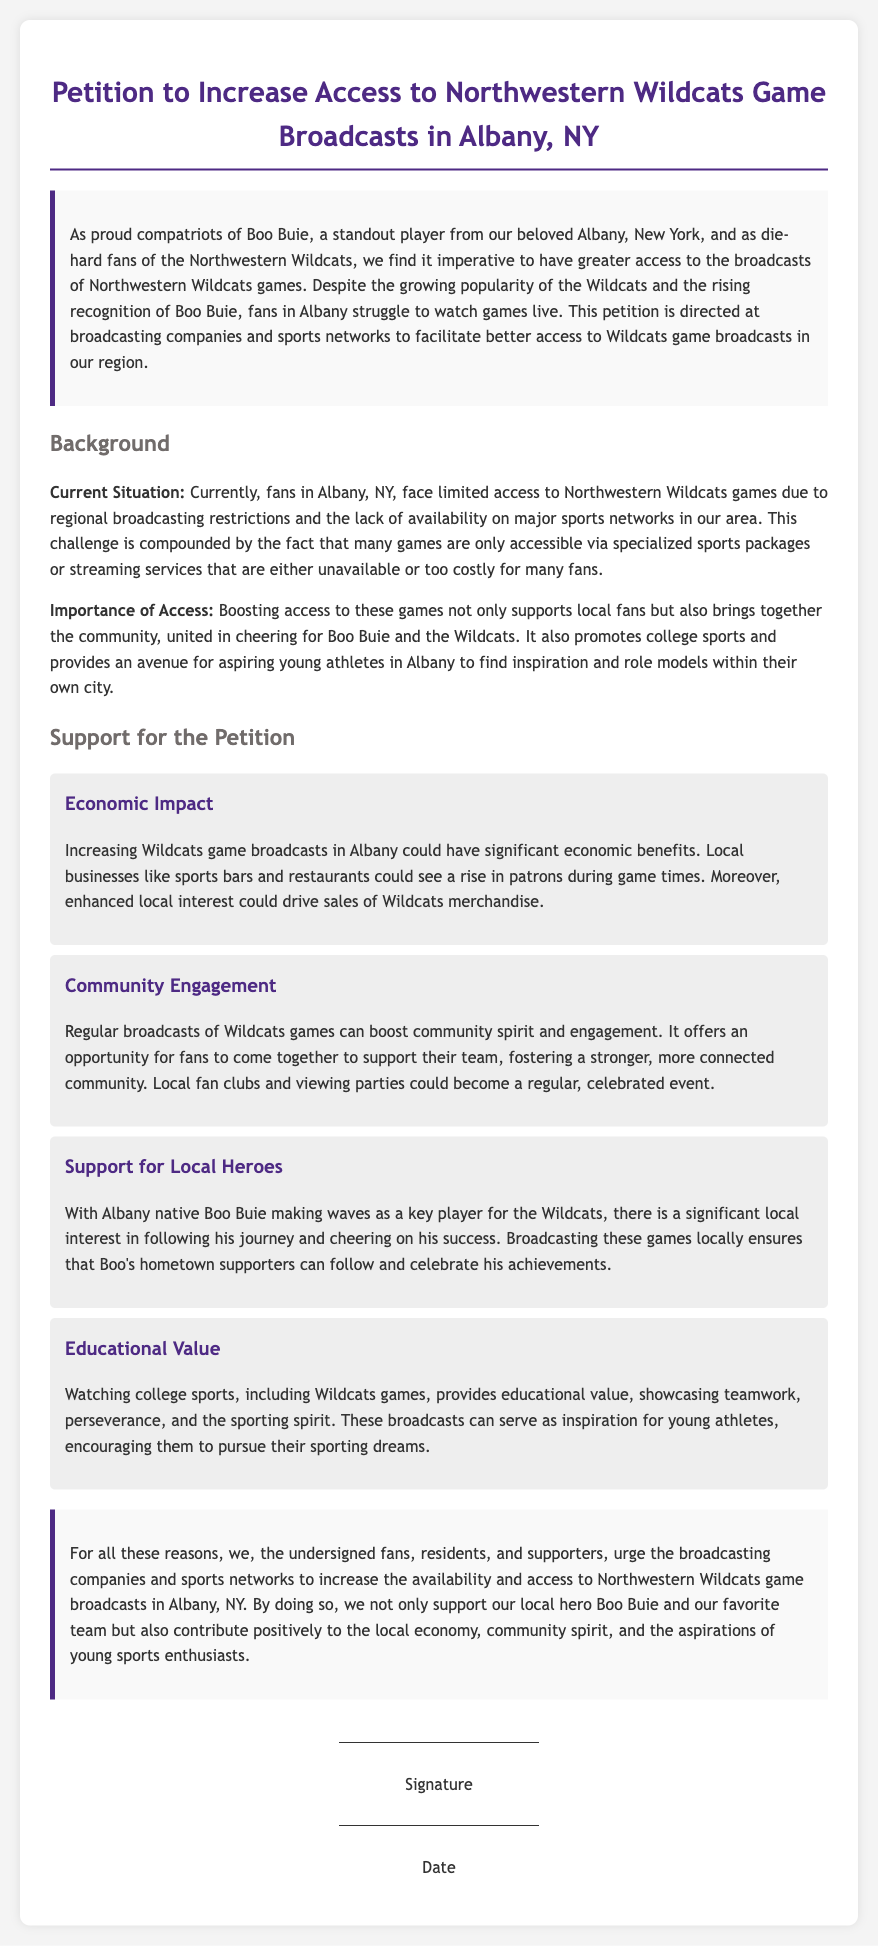What is the title of the petition? The title of the petition is stated at the top of the document.
Answer: Petition to Increase Access to Northwestern Wildcats Game Broadcasts in Albany, NY Who is referenced as a standout player from Albany? The document mentions a player who is significant to the petition and the community.
Answer: Boo Buie What is one reason for increasing broadcasts of the games? The document lists various reasons in support of the petition, including economic and community benefits.
Answer: Economic Impact What is the significance of Boo Buie in this petition? The document explains Boo Buie's importance to local fans and his connection to Albany.
Answer: Local Heroes What is mentioned as a potential benefit to local businesses? The petition discusses possible positive outcomes for certain businesses if access to games is increased.
Answer: Rise in patrons How does the petition propose to enhance community engagement? The document suggests methods for fostering community spirit through broadcasts.
Answer: Viewing parties What kind of educational value do the broadcasts provide? The petition points out the nature of the lessons that can be learned through watching the games.
Answer: Teamwork What is the overall aim of the petition? The document summarizes the main objective outlined within the text.
Answer: Increase access to broadcasts 